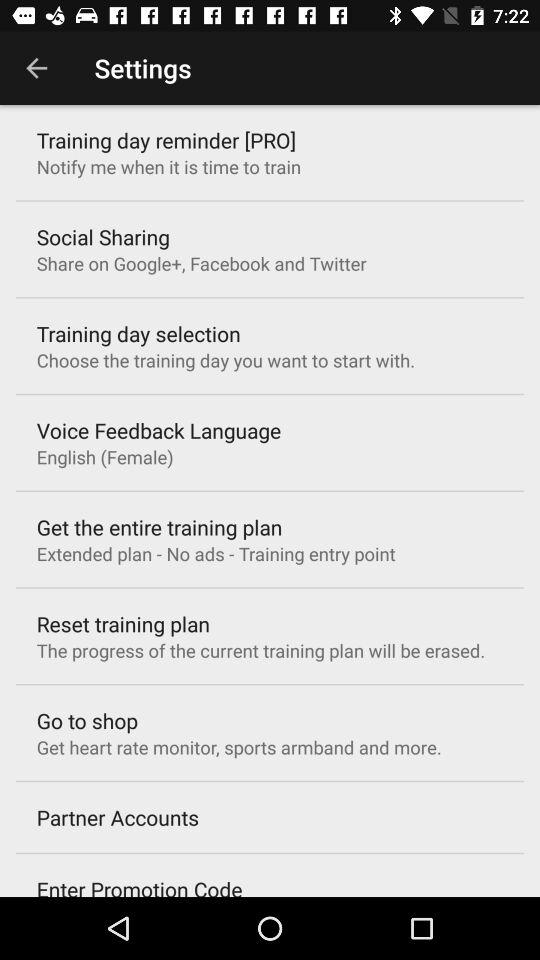Is "Partner Accounts" checked or unchecked?
When the provided information is insufficient, respond with <no answer>. <no answer> 